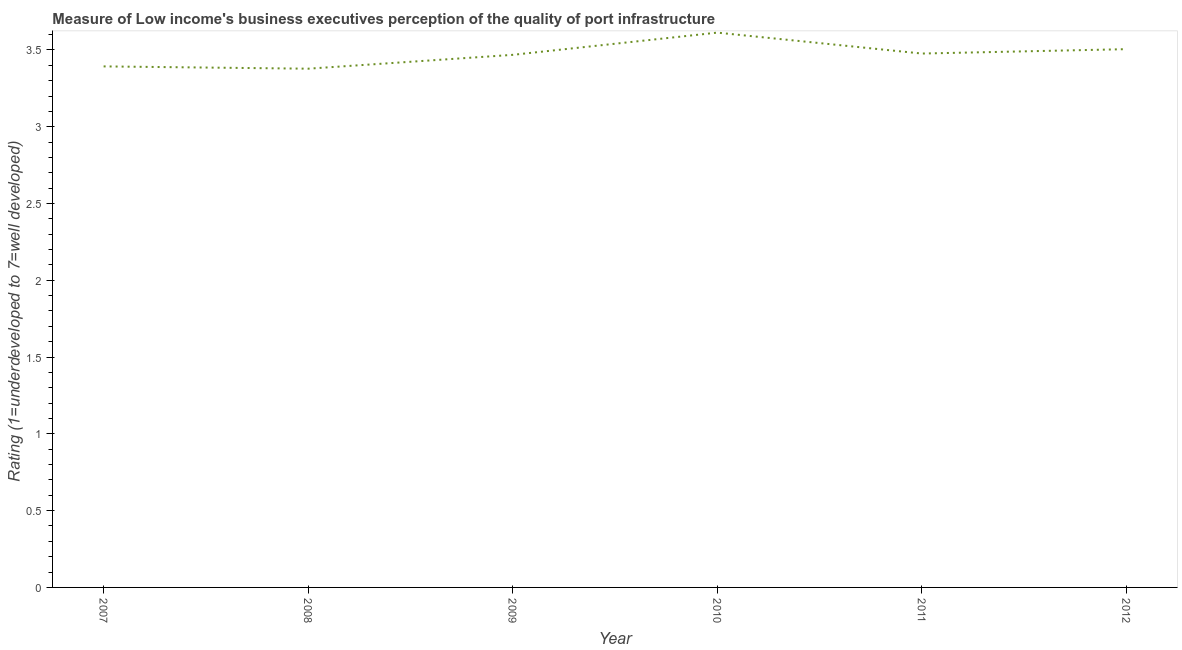What is the rating measuring quality of port infrastructure in 2011?
Offer a very short reply. 3.48. Across all years, what is the maximum rating measuring quality of port infrastructure?
Provide a short and direct response. 3.61. Across all years, what is the minimum rating measuring quality of port infrastructure?
Your response must be concise. 3.38. What is the sum of the rating measuring quality of port infrastructure?
Keep it short and to the point. 20.83. What is the difference between the rating measuring quality of port infrastructure in 2007 and 2011?
Ensure brevity in your answer.  -0.08. What is the average rating measuring quality of port infrastructure per year?
Your response must be concise. 3.47. What is the median rating measuring quality of port infrastructure?
Your answer should be very brief. 3.47. Do a majority of the years between 2009 and 2008 (inclusive) have rating measuring quality of port infrastructure greater than 0.2 ?
Give a very brief answer. No. What is the ratio of the rating measuring quality of port infrastructure in 2009 to that in 2012?
Offer a terse response. 0.99. Is the rating measuring quality of port infrastructure in 2007 less than that in 2012?
Ensure brevity in your answer.  Yes. Is the difference between the rating measuring quality of port infrastructure in 2008 and 2010 greater than the difference between any two years?
Offer a terse response. Yes. What is the difference between the highest and the second highest rating measuring quality of port infrastructure?
Offer a terse response. 0.11. What is the difference between the highest and the lowest rating measuring quality of port infrastructure?
Your answer should be compact. 0.23. In how many years, is the rating measuring quality of port infrastructure greater than the average rating measuring quality of port infrastructure taken over all years?
Ensure brevity in your answer.  3. Does the rating measuring quality of port infrastructure monotonically increase over the years?
Offer a terse response. No. What is the title of the graph?
Provide a succinct answer. Measure of Low income's business executives perception of the quality of port infrastructure. What is the label or title of the X-axis?
Offer a very short reply. Year. What is the label or title of the Y-axis?
Your response must be concise. Rating (1=underdeveloped to 7=well developed) . What is the Rating (1=underdeveloped to 7=well developed)  in 2007?
Offer a terse response. 3.39. What is the Rating (1=underdeveloped to 7=well developed)  in 2008?
Offer a terse response. 3.38. What is the Rating (1=underdeveloped to 7=well developed)  in 2009?
Provide a succinct answer. 3.47. What is the Rating (1=underdeveloped to 7=well developed)  of 2010?
Make the answer very short. 3.61. What is the Rating (1=underdeveloped to 7=well developed)  in 2011?
Your answer should be compact. 3.48. What is the Rating (1=underdeveloped to 7=well developed)  in 2012?
Your response must be concise. 3.5. What is the difference between the Rating (1=underdeveloped to 7=well developed)  in 2007 and 2008?
Offer a very short reply. 0.01. What is the difference between the Rating (1=underdeveloped to 7=well developed)  in 2007 and 2009?
Provide a succinct answer. -0.08. What is the difference between the Rating (1=underdeveloped to 7=well developed)  in 2007 and 2010?
Your answer should be very brief. -0.22. What is the difference between the Rating (1=underdeveloped to 7=well developed)  in 2007 and 2011?
Offer a terse response. -0.08. What is the difference between the Rating (1=underdeveloped to 7=well developed)  in 2007 and 2012?
Offer a very short reply. -0.11. What is the difference between the Rating (1=underdeveloped to 7=well developed)  in 2008 and 2009?
Provide a short and direct response. -0.09. What is the difference between the Rating (1=underdeveloped to 7=well developed)  in 2008 and 2010?
Offer a very short reply. -0.23. What is the difference between the Rating (1=underdeveloped to 7=well developed)  in 2008 and 2011?
Offer a very short reply. -0.1. What is the difference between the Rating (1=underdeveloped to 7=well developed)  in 2008 and 2012?
Ensure brevity in your answer.  -0.13. What is the difference between the Rating (1=underdeveloped to 7=well developed)  in 2009 and 2010?
Your answer should be compact. -0.14. What is the difference between the Rating (1=underdeveloped to 7=well developed)  in 2009 and 2011?
Offer a very short reply. -0.01. What is the difference between the Rating (1=underdeveloped to 7=well developed)  in 2009 and 2012?
Ensure brevity in your answer.  -0.04. What is the difference between the Rating (1=underdeveloped to 7=well developed)  in 2010 and 2011?
Offer a very short reply. 0.14. What is the difference between the Rating (1=underdeveloped to 7=well developed)  in 2010 and 2012?
Your response must be concise. 0.11. What is the difference between the Rating (1=underdeveloped to 7=well developed)  in 2011 and 2012?
Keep it short and to the point. -0.03. What is the ratio of the Rating (1=underdeveloped to 7=well developed)  in 2007 to that in 2010?
Offer a terse response. 0.94. What is the ratio of the Rating (1=underdeveloped to 7=well developed)  in 2007 to that in 2011?
Ensure brevity in your answer.  0.98. What is the ratio of the Rating (1=underdeveloped to 7=well developed)  in 2007 to that in 2012?
Give a very brief answer. 0.97. What is the ratio of the Rating (1=underdeveloped to 7=well developed)  in 2008 to that in 2010?
Your response must be concise. 0.94. What is the ratio of the Rating (1=underdeveloped to 7=well developed)  in 2008 to that in 2011?
Offer a terse response. 0.97. What is the ratio of the Rating (1=underdeveloped to 7=well developed)  in 2009 to that in 2011?
Give a very brief answer. 1. What is the ratio of the Rating (1=underdeveloped to 7=well developed)  in 2009 to that in 2012?
Your answer should be very brief. 0.99. What is the ratio of the Rating (1=underdeveloped to 7=well developed)  in 2010 to that in 2011?
Provide a short and direct response. 1.04. What is the ratio of the Rating (1=underdeveloped to 7=well developed)  in 2010 to that in 2012?
Your answer should be compact. 1.03. What is the ratio of the Rating (1=underdeveloped to 7=well developed)  in 2011 to that in 2012?
Your response must be concise. 0.99. 